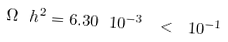Convert formula to latex. <formula><loc_0><loc_0><loc_500><loc_500>\Omega \ h ^ { 2 } = 6 . 3 0 \ 1 0 ^ { - 3 } \ < \ 1 0 ^ { - 1 }</formula> 